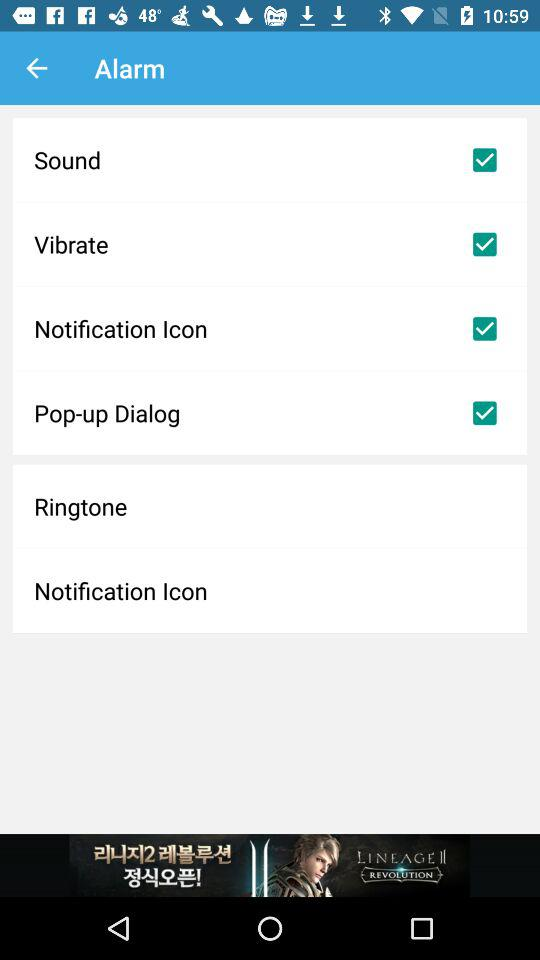What is the status of "Sound"? The status is "on". 